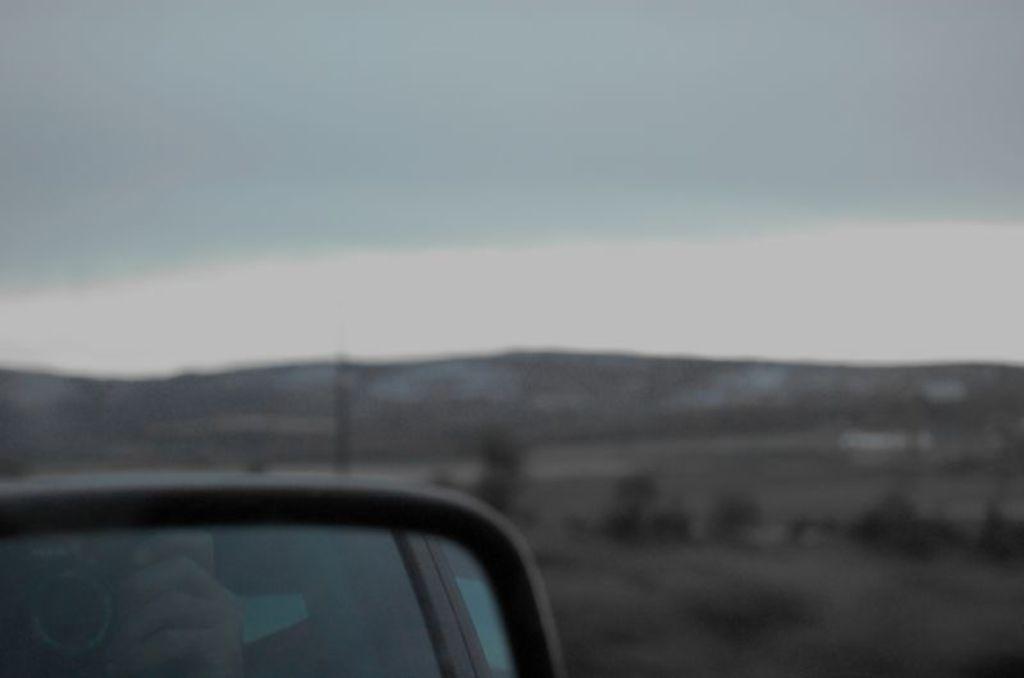Describe this image in one or two sentences. In this picture we can observe a mirror of a vehicle. We can observe some plants on the ground. In the background there are hills and a sky. 